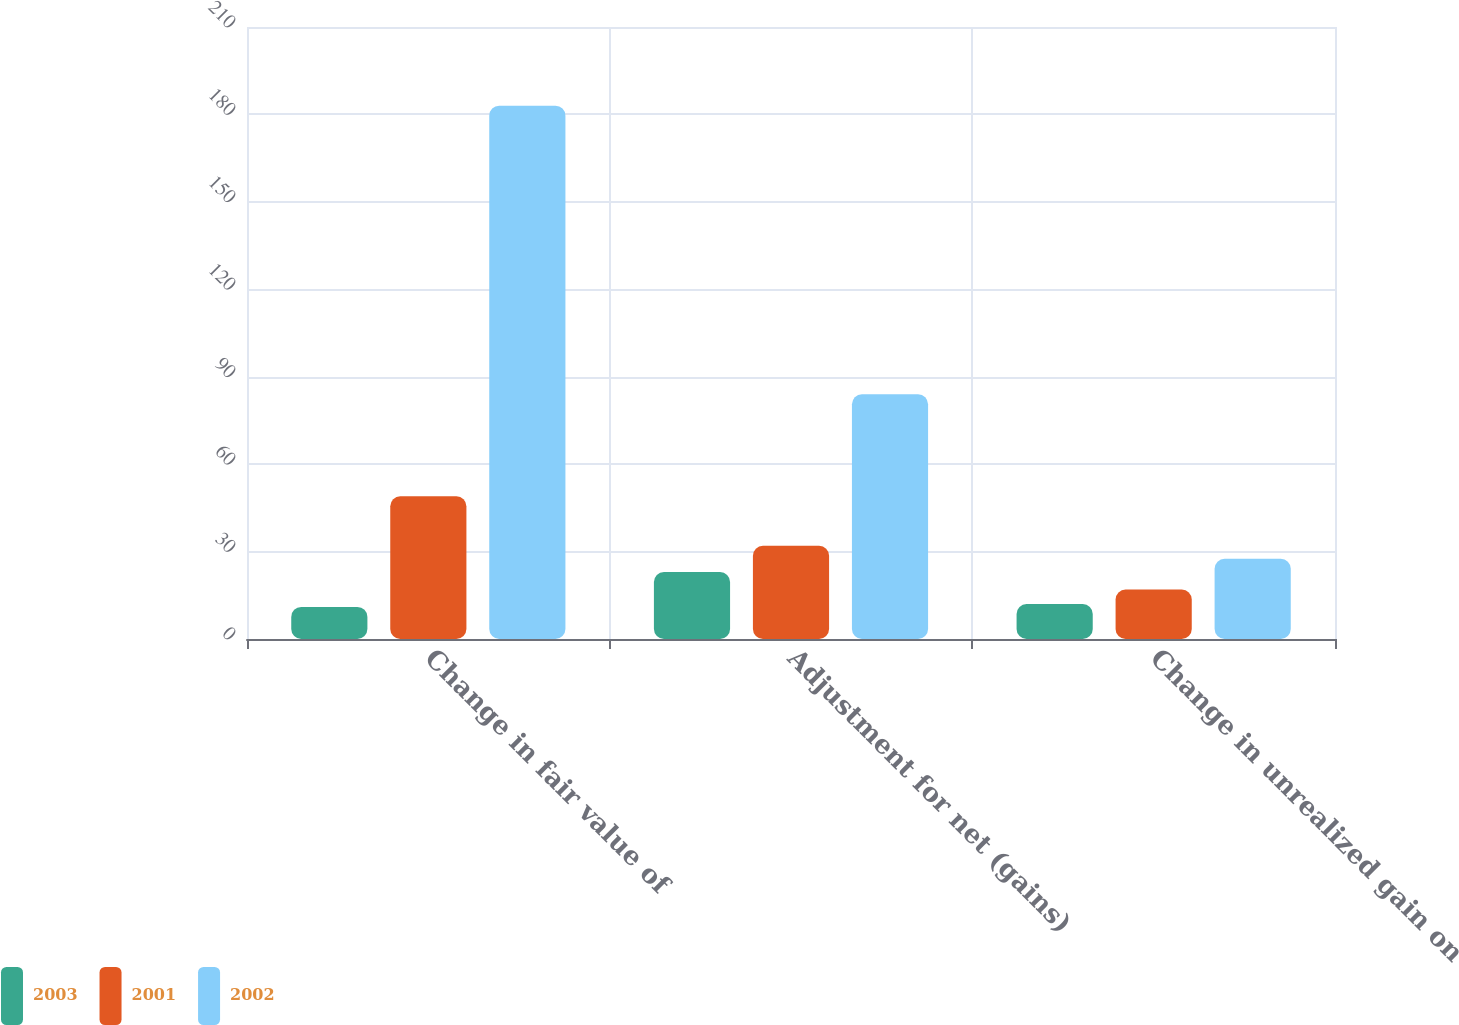<chart> <loc_0><loc_0><loc_500><loc_500><stacked_bar_chart><ecel><fcel>Change in fair value of<fcel>Adjustment for net (gains)<fcel>Change in unrealized gain on<nl><fcel>2003<fcel>11<fcel>23<fcel>12<nl><fcel>2001<fcel>49<fcel>32<fcel>17<nl><fcel>2002<fcel>183<fcel>84<fcel>27.5<nl></chart> 